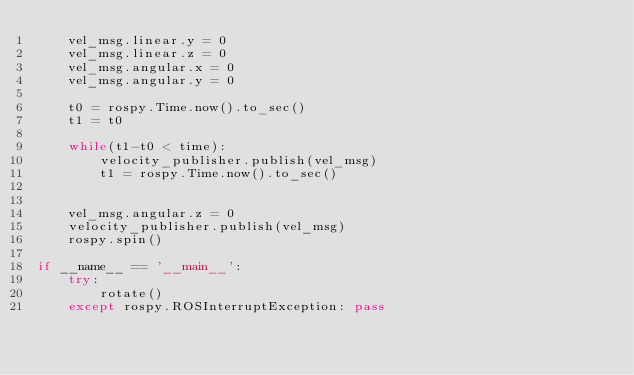Convert code to text. <code><loc_0><loc_0><loc_500><loc_500><_Python_>    vel_msg.linear.y = 0
    vel_msg.linear.z = 0
    vel_msg.angular.x = 0
    vel_msg.angular.y = 0

    t0 = rospy.Time.now().to_sec()
    t1 = t0

    while(t1-t0 < time):
        velocity_publisher.publish(vel_msg)
        t1 = rospy.Time.now().to_sec()


    vel_msg.angular.z = 0
    velocity_publisher.publish(vel_msg)
    rospy.spin()

if __name__ == '__main__':
    try:
        rotate()
    except rospy.ROSInterruptException: pass
</code> 